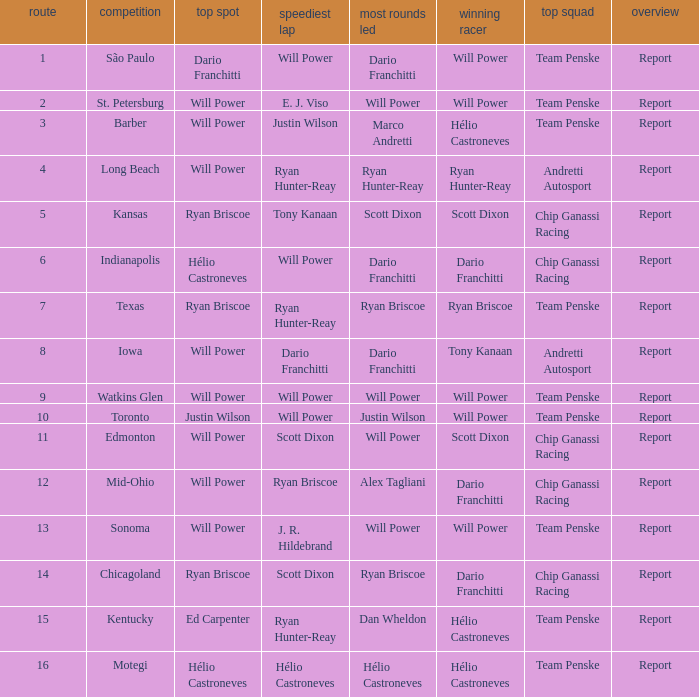In what position did the winning driver finish at Chicagoland? 1.0. 